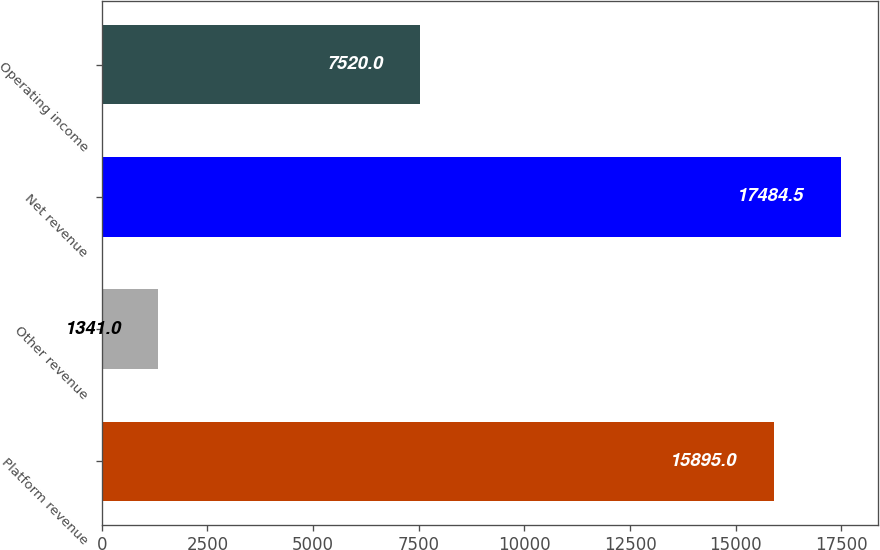<chart> <loc_0><loc_0><loc_500><loc_500><bar_chart><fcel>Platform revenue<fcel>Other revenue<fcel>Net revenue<fcel>Operating income<nl><fcel>15895<fcel>1341<fcel>17484.5<fcel>7520<nl></chart> 